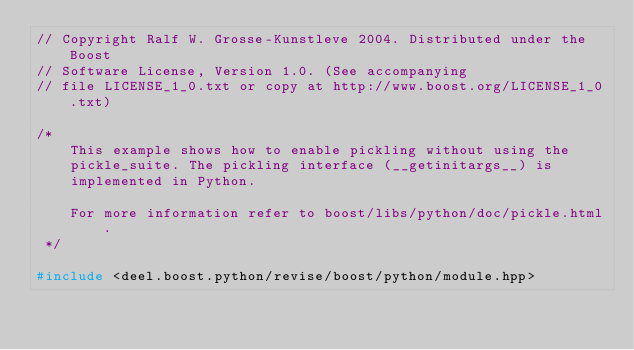Convert code to text. <code><loc_0><loc_0><loc_500><loc_500><_C++_>// Copyright Ralf W. Grosse-Kunstleve 2004. Distributed under the Boost
// Software License, Version 1.0. (See accompanying
// file LICENSE_1_0.txt or copy at http://www.boost.org/LICENSE_1_0.txt)

/*
    This example shows how to enable pickling without using the
    pickle_suite. The pickling interface (__getinitargs__) is
    implemented in Python.

    For more information refer to boost/libs/python/doc/pickle.html.
 */

#include <deel.boost.python/revise/boost/python/module.hpp></code> 